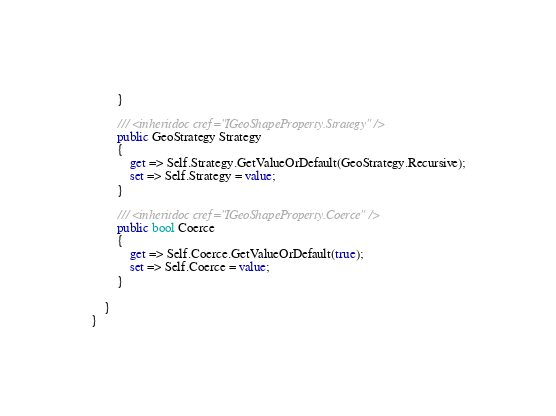Convert code to text. <code><loc_0><loc_0><loc_500><loc_500><_C#_>		}

		/// <inheritdoc cref="IGeoShapeProperty.Strategy" />
		public GeoStrategy Strategy
		{
			get => Self.Strategy.GetValueOrDefault(GeoStrategy.Recursive);
			set => Self.Strategy = value;
		}

		/// <inheritdoc cref="IGeoShapeProperty.Coerce" />
		public bool Coerce
		{
			get => Self.Coerce.GetValueOrDefault(true);
			set => Self.Coerce = value;
		}

	}
}
</code> 